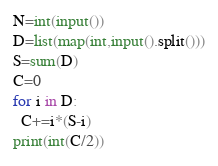<code> <loc_0><loc_0><loc_500><loc_500><_Python_>N=int(input())
D=list(map(int,input().split()))
S=sum(D)
C=0
for i in D:
  C+=i*(S-i)
print(int(C/2))</code> 